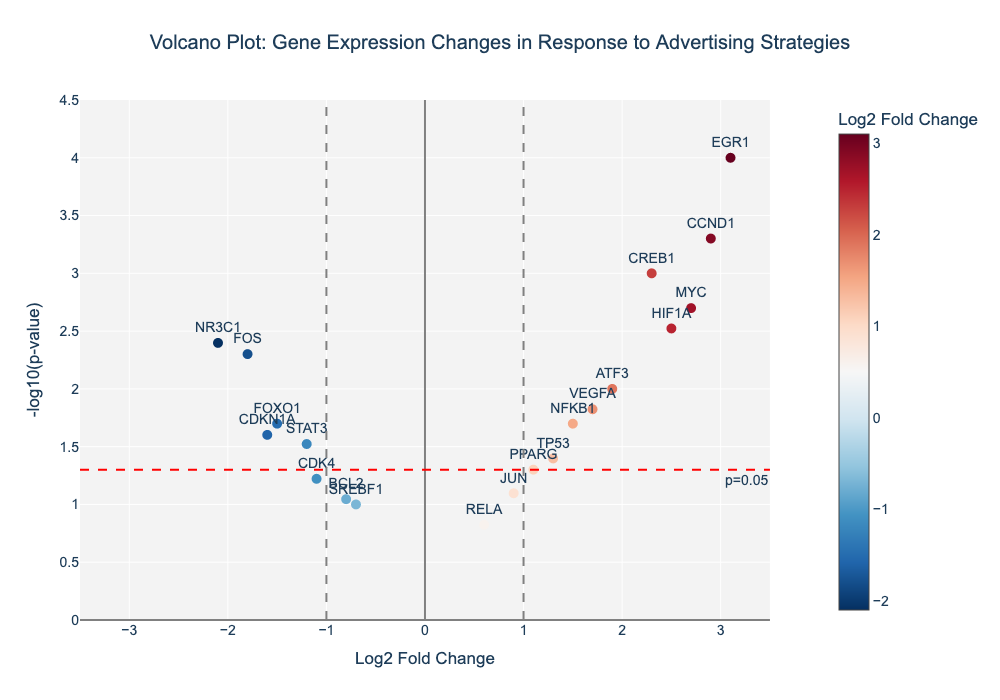Which gene has the highest -log10(p-value)? The plot gives -log10(p-value) on the y-axis. The gene EGR1 is plotted at the highest location on this axis.
Answer: EGR1 How many genes are significantly up-regulated with a p-value less than 0.05? The horizontal red dashed line represents the p-value threshold of 0.05, and up-regulation is represented by a Log2 Fold Change greater than 0. There are 6 genes above this line with Log2 Fold Change greater than 0 (CREB1, NFKB1, EGR1, MYC, HIF1A, VEGFA).
Answer: 6 Which genes have a Log2 Fold Change (Log2FC) greater than 2? The x-axis represents the Log2 Fold Change. Genes with their symbols positioned to the right of the 2 mark (EGR1, MYC) fit this criterion.
Answer: EGR1, MYC What is the Log2 Fold Change for the gene FOS? Locate gene FOS on the plot and note its position on the x-axis. The Log2 Fold Change for FOS is near -2.
Answer: -1.8 Which genes are down-regulated with Log2 Fold Change less than -1 and significant with p-value less than 0.05? Down-regulated genes have a Log2 Fold Change less than -1. Locate genes below -1 on the x-axis and above the red dashed line (below p-value 0.05). The genes STAT3, NR3C1, FOXO1, CDKN1A fit this criterion.
Answer: STAT3, NR3C1, FOXO1, CDKN1A 